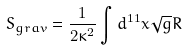<formula> <loc_0><loc_0><loc_500><loc_500>S _ { g r a v } = \frac { 1 } { 2 \kappa ^ { 2 } } \int d ^ { 1 1 } x \sqrt { g } R</formula> 